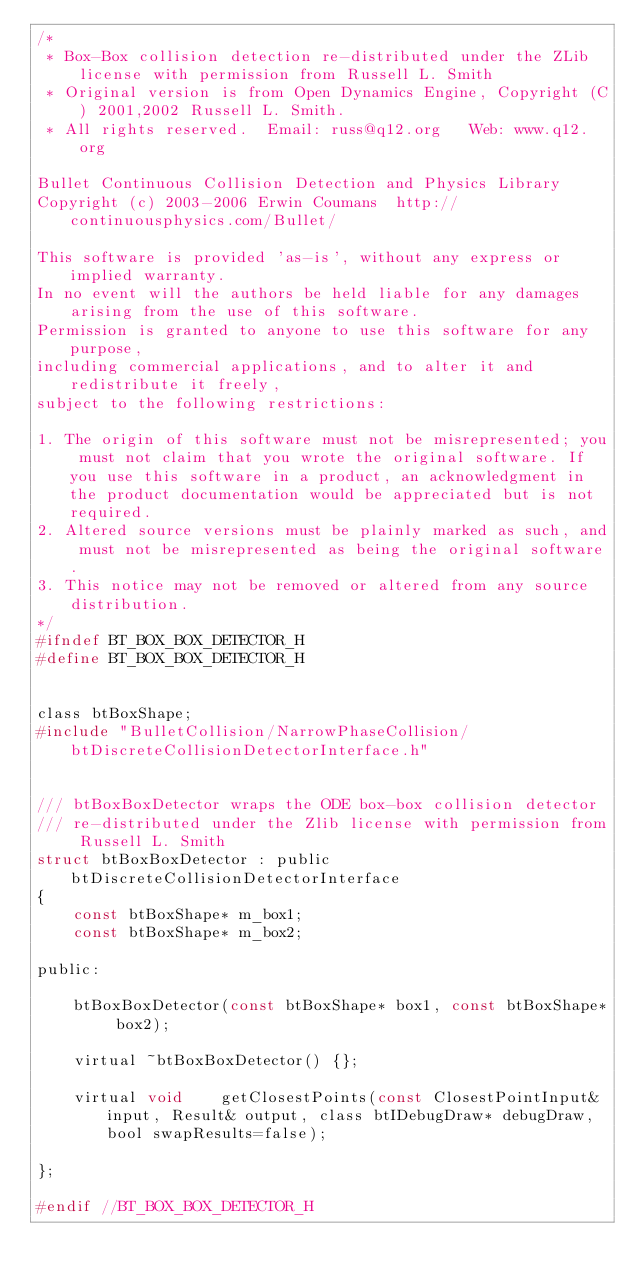<code> <loc_0><loc_0><loc_500><loc_500><_C_>/*
 * Box-Box collision detection re-distributed under the ZLib license with permission from Russell L. Smith
 * Original version is from Open Dynamics Engine, Copyright (C) 2001,2002 Russell L. Smith.
 * All rights reserved.  Email: russ@q12.org   Web: www.q12.org

Bullet Continuous Collision Detection and Physics Library
Copyright (c) 2003-2006 Erwin Coumans  http://continuousphysics.com/Bullet/

This software is provided 'as-is', without any express or implied warranty.
In no event will the authors be held liable for any damages arising from the use of this software.
Permission is granted to anyone to use this software for any purpose, 
including commercial applications, and to alter it and redistribute it freely, 
subject to the following restrictions:

1. The origin of this software must not be misrepresented; you must not claim that you wrote the original software. If you use this software in a product, an acknowledgment in the product documentation would be appreciated but is not required.
2. Altered source versions must be plainly marked as such, and must not be misrepresented as being the original software.
3. This notice may not be removed or altered from any source distribution.
*/
#ifndef BT_BOX_BOX_DETECTOR_H
#define BT_BOX_BOX_DETECTOR_H


class btBoxShape;
#include "BulletCollision/NarrowPhaseCollision/btDiscreteCollisionDetectorInterface.h"


/// btBoxBoxDetector wraps the ODE box-box collision detector
/// re-distributed under the Zlib license with permission from Russell L. Smith
struct btBoxBoxDetector : public btDiscreteCollisionDetectorInterface
{
	const btBoxShape* m_box1;
	const btBoxShape* m_box2;

public:

	btBoxBoxDetector(const btBoxShape* box1, const btBoxShape* box2);

	virtual ~btBoxBoxDetector() {};

	virtual void	getClosestPoints(const ClosestPointInput& input, Result& output, class btIDebugDraw* debugDraw, bool swapResults=false);

};

#endif //BT_BOX_BOX_DETECTOR_H
</code> 